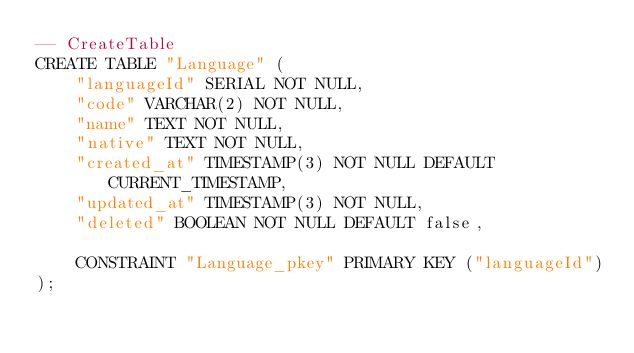Convert code to text. <code><loc_0><loc_0><loc_500><loc_500><_SQL_>-- CreateTable
CREATE TABLE "Language" (
    "languageId" SERIAL NOT NULL,
    "code" VARCHAR(2) NOT NULL,
    "name" TEXT NOT NULL,
    "native" TEXT NOT NULL,
    "created_at" TIMESTAMP(3) NOT NULL DEFAULT CURRENT_TIMESTAMP,
    "updated_at" TIMESTAMP(3) NOT NULL,
    "deleted" BOOLEAN NOT NULL DEFAULT false,

    CONSTRAINT "Language_pkey" PRIMARY KEY ("languageId")
);
</code> 